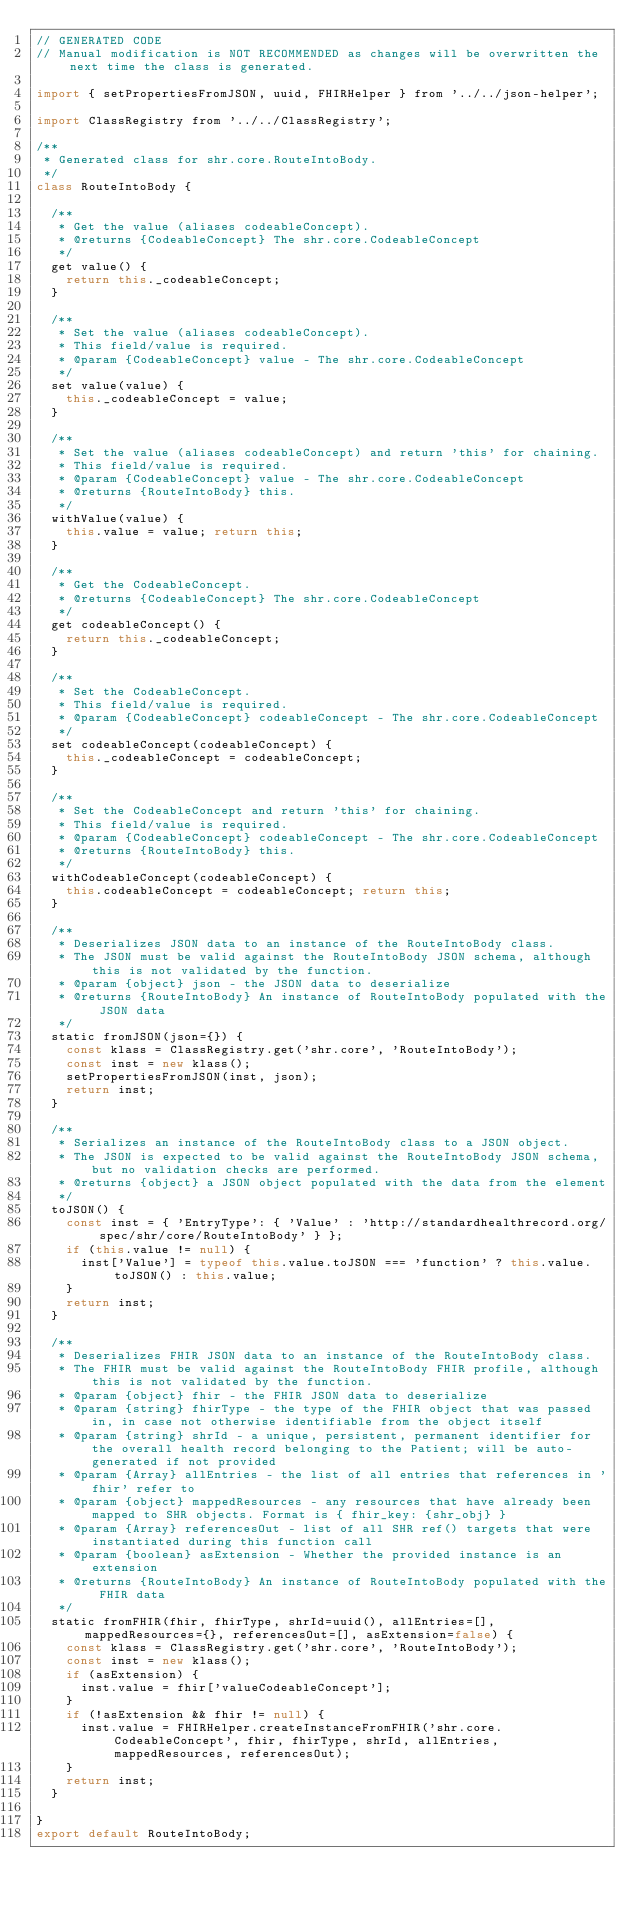<code> <loc_0><loc_0><loc_500><loc_500><_JavaScript_>// GENERATED CODE
// Manual modification is NOT RECOMMENDED as changes will be overwritten the next time the class is generated.

import { setPropertiesFromJSON, uuid, FHIRHelper } from '../../json-helper';

import ClassRegistry from '../../ClassRegistry';

/**
 * Generated class for shr.core.RouteIntoBody.
 */
class RouteIntoBody {

  /**
   * Get the value (aliases codeableConcept).
   * @returns {CodeableConcept} The shr.core.CodeableConcept
   */
  get value() {
    return this._codeableConcept;
  }

  /**
   * Set the value (aliases codeableConcept).
   * This field/value is required.
   * @param {CodeableConcept} value - The shr.core.CodeableConcept
   */
  set value(value) {
    this._codeableConcept = value;
  }

  /**
   * Set the value (aliases codeableConcept) and return 'this' for chaining.
   * This field/value is required.
   * @param {CodeableConcept} value - The shr.core.CodeableConcept
   * @returns {RouteIntoBody} this.
   */
  withValue(value) {
    this.value = value; return this;
  }

  /**
   * Get the CodeableConcept.
   * @returns {CodeableConcept} The shr.core.CodeableConcept
   */
  get codeableConcept() {
    return this._codeableConcept;
  }

  /**
   * Set the CodeableConcept.
   * This field/value is required.
   * @param {CodeableConcept} codeableConcept - The shr.core.CodeableConcept
   */
  set codeableConcept(codeableConcept) {
    this._codeableConcept = codeableConcept;
  }

  /**
   * Set the CodeableConcept and return 'this' for chaining.
   * This field/value is required.
   * @param {CodeableConcept} codeableConcept - The shr.core.CodeableConcept
   * @returns {RouteIntoBody} this.
   */
  withCodeableConcept(codeableConcept) {
    this.codeableConcept = codeableConcept; return this;
  }

  /**
   * Deserializes JSON data to an instance of the RouteIntoBody class.
   * The JSON must be valid against the RouteIntoBody JSON schema, although this is not validated by the function.
   * @param {object} json - the JSON data to deserialize
   * @returns {RouteIntoBody} An instance of RouteIntoBody populated with the JSON data
   */
  static fromJSON(json={}) {
    const klass = ClassRegistry.get('shr.core', 'RouteIntoBody');
    const inst = new klass();
    setPropertiesFromJSON(inst, json);
    return inst;
  }

  /**
   * Serializes an instance of the RouteIntoBody class to a JSON object.
   * The JSON is expected to be valid against the RouteIntoBody JSON schema, but no validation checks are performed.
   * @returns {object} a JSON object populated with the data from the element
   */
  toJSON() {
    const inst = { 'EntryType': { 'Value' : 'http://standardhealthrecord.org/spec/shr/core/RouteIntoBody' } };
    if (this.value != null) {
      inst['Value'] = typeof this.value.toJSON === 'function' ? this.value.toJSON() : this.value;
    }
    return inst;
  }

  /**
   * Deserializes FHIR JSON data to an instance of the RouteIntoBody class.
   * The FHIR must be valid against the RouteIntoBody FHIR profile, although this is not validated by the function.
   * @param {object} fhir - the FHIR JSON data to deserialize
   * @param {string} fhirType - the type of the FHIR object that was passed in, in case not otherwise identifiable from the object itself
   * @param {string} shrId - a unique, persistent, permanent identifier for the overall health record belonging to the Patient; will be auto-generated if not provided
   * @param {Array} allEntries - the list of all entries that references in 'fhir' refer to
   * @param {object} mappedResources - any resources that have already been mapped to SHR objects. Format is { fhir_key: {shr_obj} }
   * @param {Array} referencesOut - list of all SHR ref() targets that were instantiated during this function call
   * @param {boolean} asExtension - Whether the provided instance is an extension
   * @returns {RouteIntoBody} An instance of RouteIntoBody populated with the FHIR data
   */
  static fromFHIR(fhir, fhirType, shrId=uuid(), allEntries=[], mappedResources={}, referencesOut=[], asExtension=false) {
    const klass = ClassRegistry.get('shr.core', 'RouteIntoBody');
    const inst = new klass();
    if (asExtension) {
      inst.value = fhir['valueCodeableConcept'];
    }
    if (!asExtension && fhir != null) {
      inst.value = FHIRHelper.createInstanceFromFHIR('shr.core.CodeableConcept', fhir, fhirType, shrId, allEntries, mappedResources, referencesOut);
    }
    return inst;
  }

}
export default RouteIntoBody;
</code> 